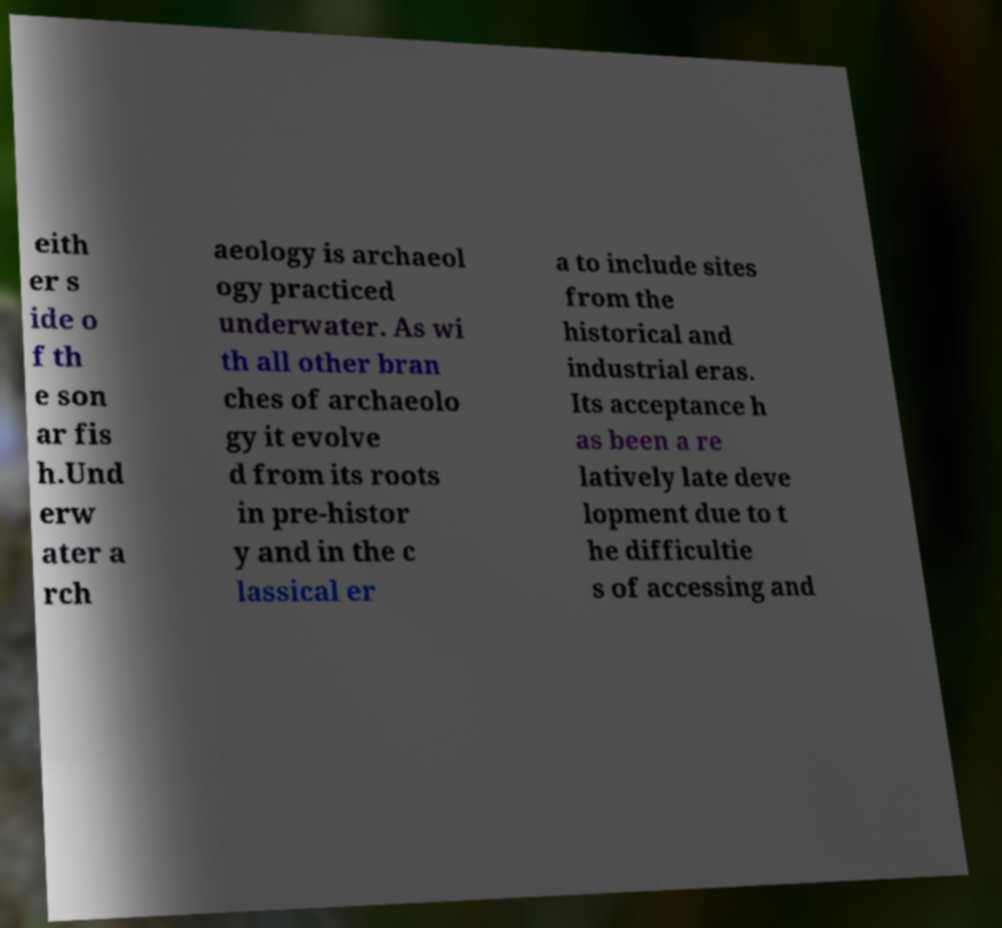Could you extract and type out the text from this image? eith er s ide o f th e son ar fis h.Und erw ater a rch aeology is archaeol ogy practiced underwater. As wi th all other bran ches of archaeolo gy it evolve d from its roots in pre-histor y and in the c lassical er a to include sites from the historical and industrial eras. Its acceptance h as been a re latively late deve lopment due to t he difficultie s of accessing and 